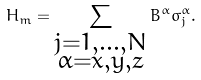<formula> <loc_0><loc_0><loc_500><loc_500>H _ { m } = \sum _ { \substack { j = 1 , \dots , N \\ \alpha = x , y , z } } B ^ { \alpha } \sigma _ { j } ^ { \alpha } .</formula> 